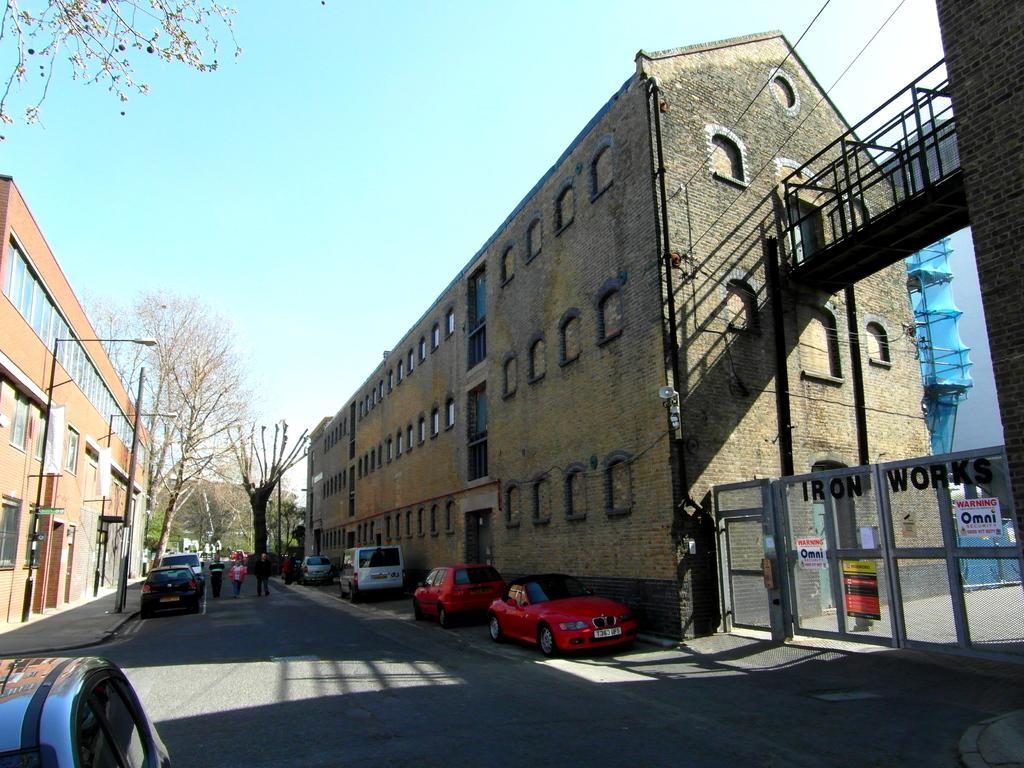Could you give a brief overview of what you see in this image? In the foreground of this image, there is a road and few vehicles are parked a side to the road. In the background, there are buildings, trees, poles, gate and the sky. 